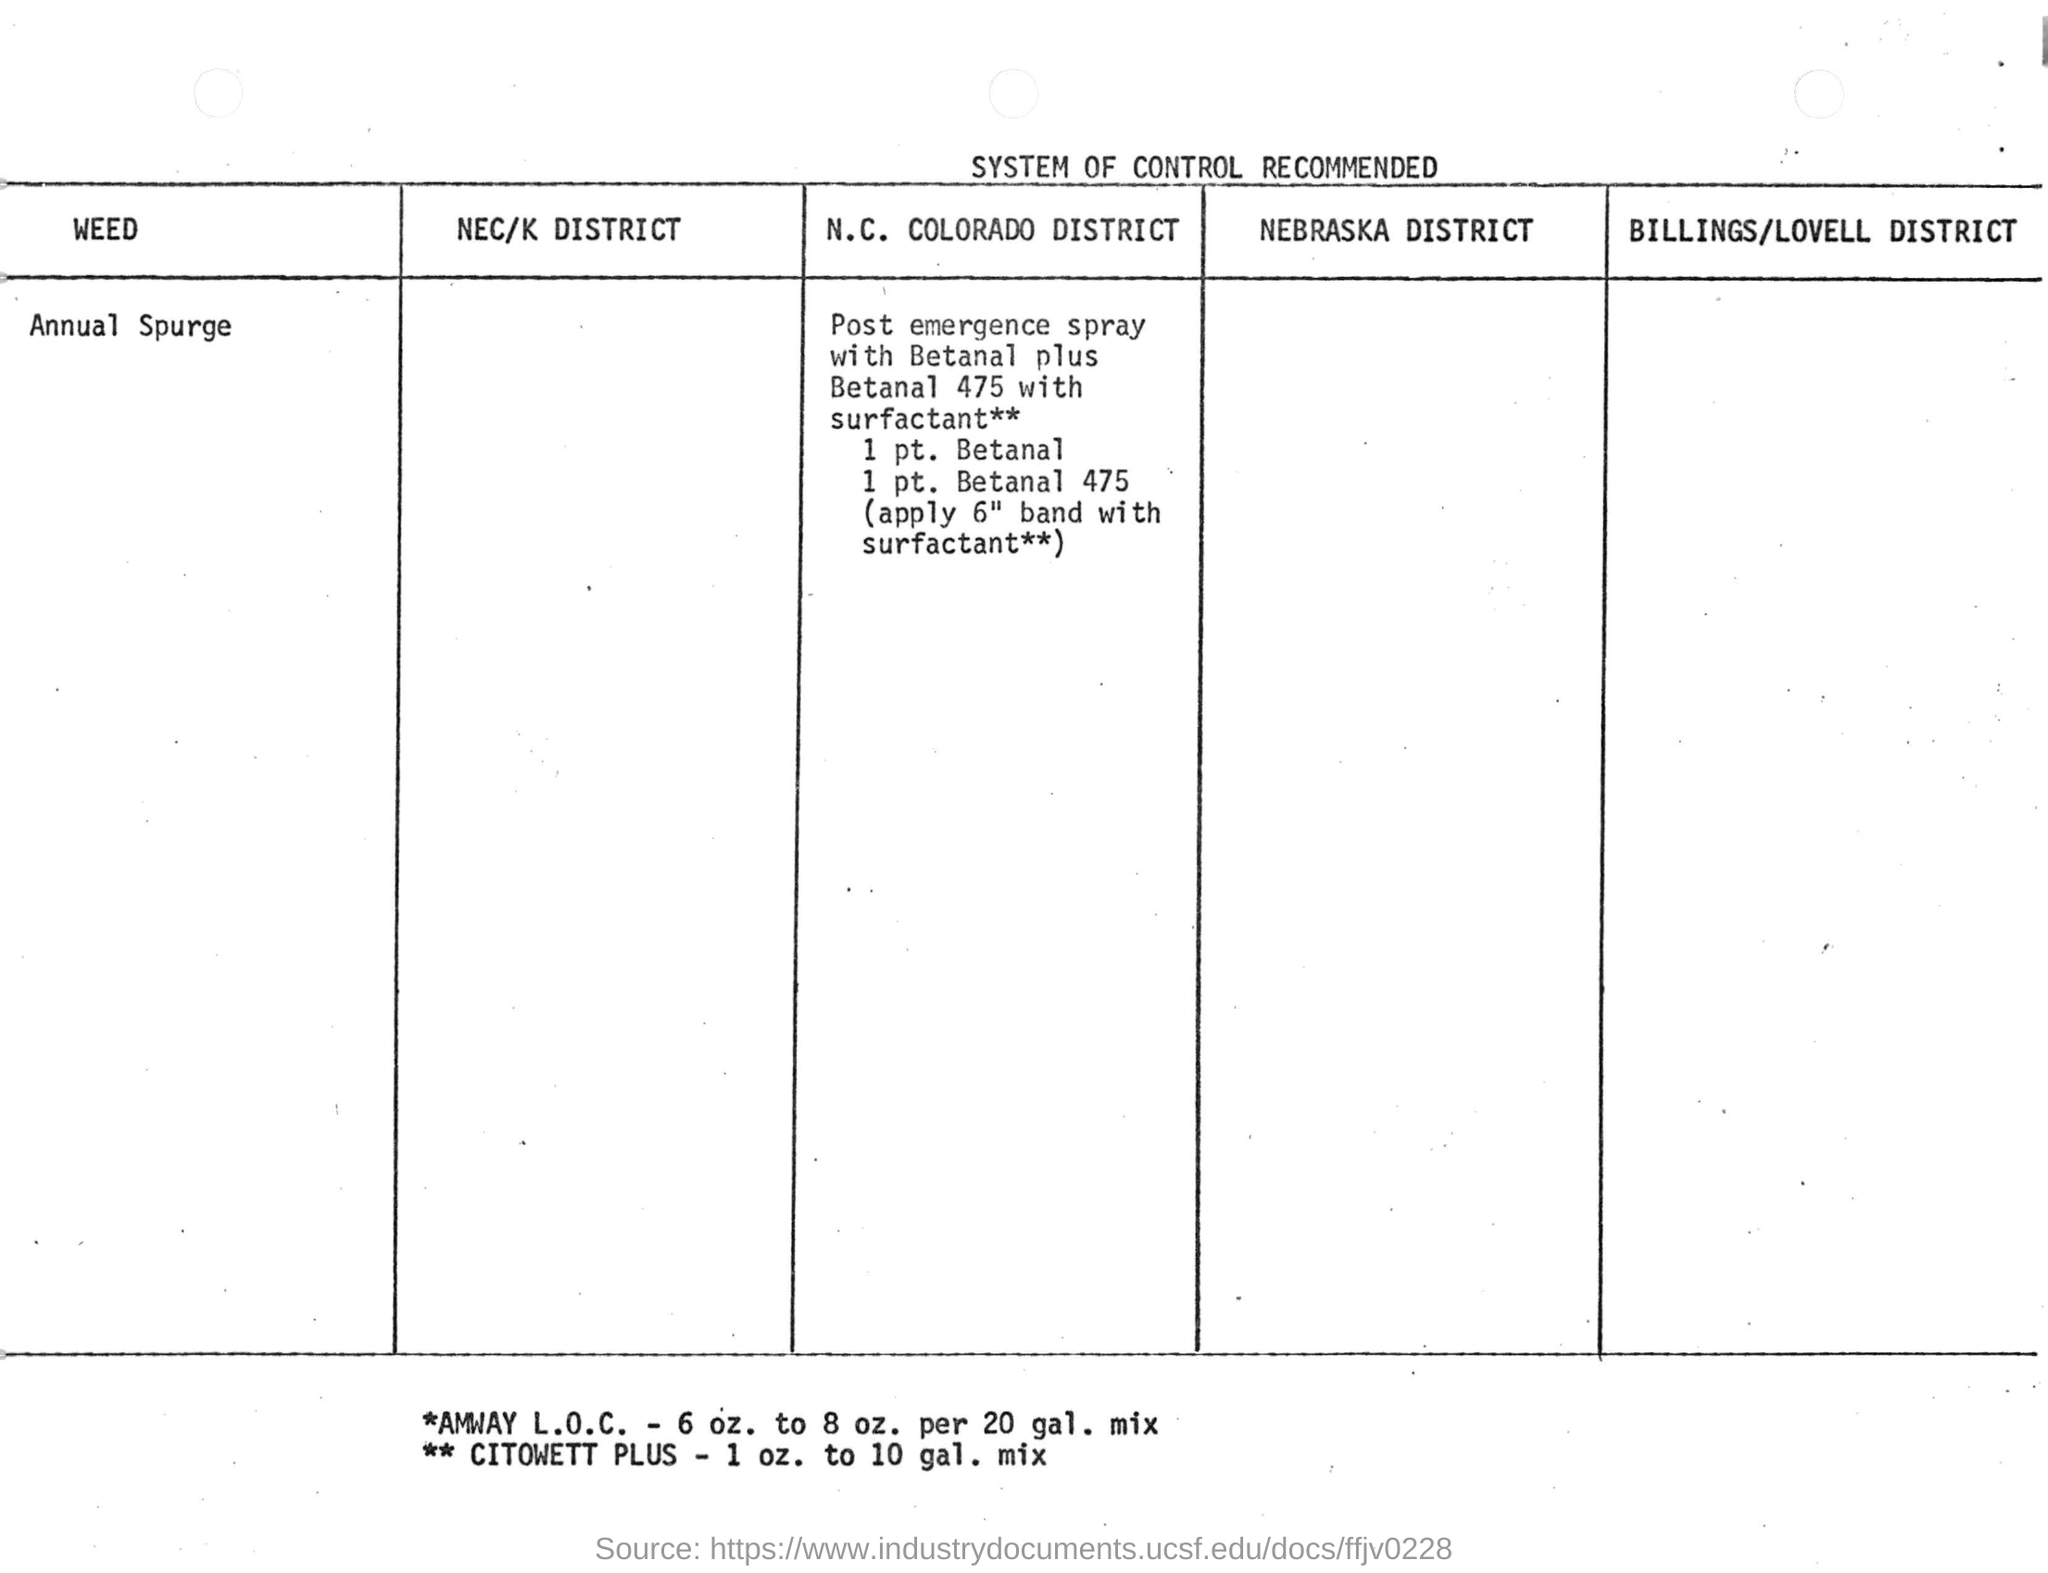What is the weed to be controlled?
Provide a short and direct response. Annual spurge. In which district annual spurge to be controlled using post emergence spray?
Your response must be concise. N. c. colorado district. Which weed is listed in this table?
Ensure brevity in your answer.  Annual Spurge. How much band width are applied with surfactant** to control annual spurge weed ?
Provide a short and direct response. 6". 